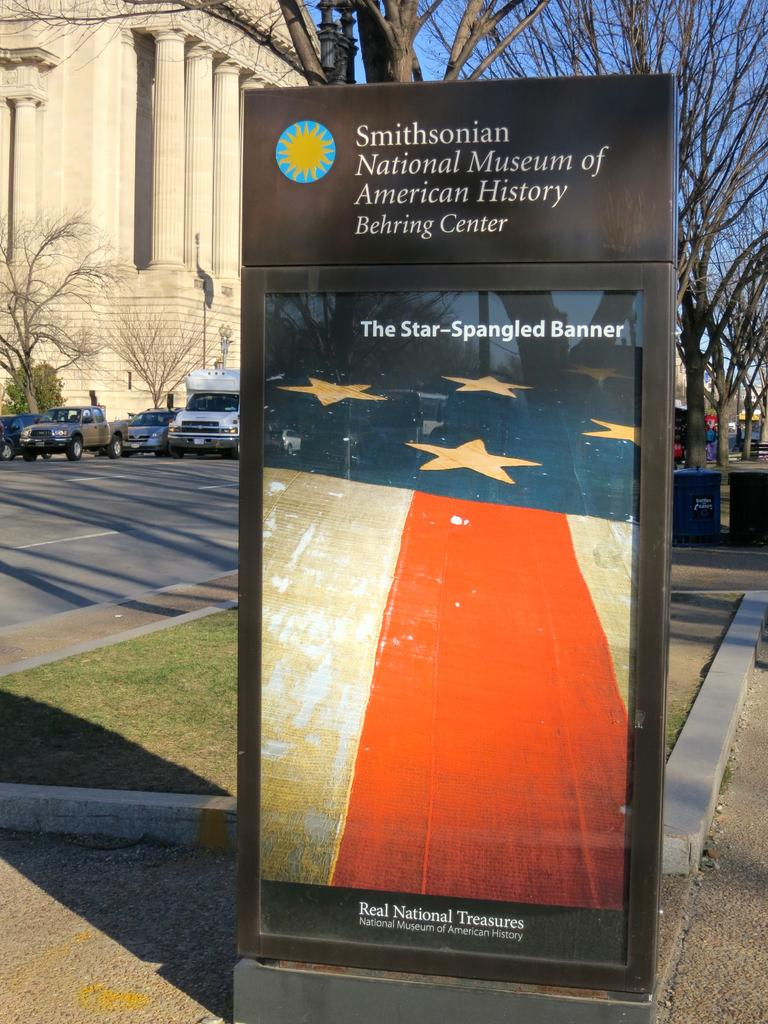Provide a one-sentence caption for the provided image. An advertisement for a Smithsonian museum shows a picture of the American flag. 